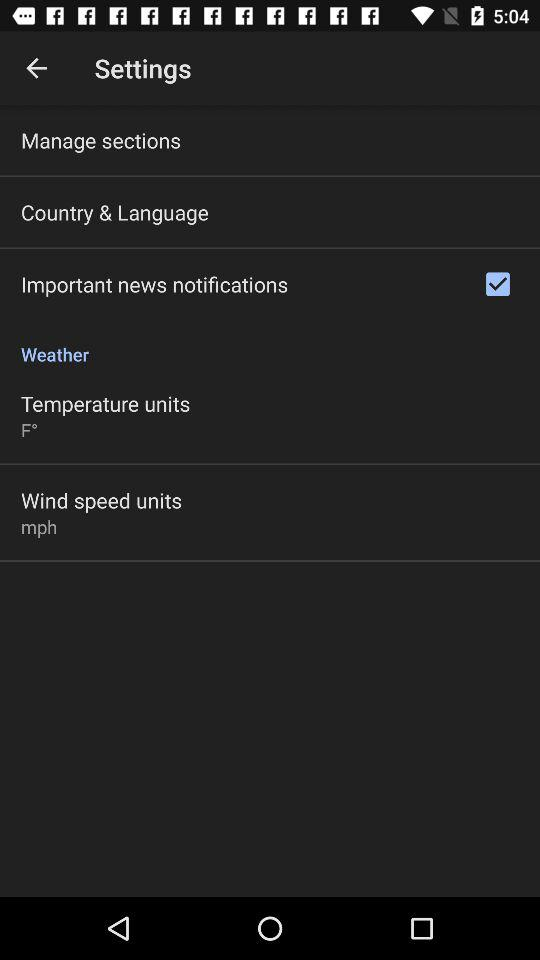Which option is selected? The selected option is "Important news notifications". 